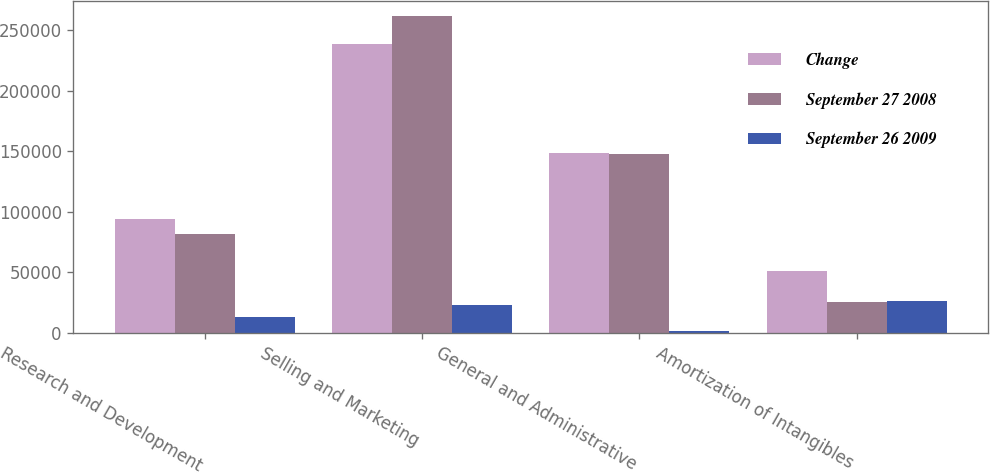<chart> <loc_0><loc_0><loc_500><loc_500><stacked_bar_chart><ecel><fcel>Research and Development<fcel>Selling and Marketing<fcel>General and Administrative<fcel>Amortization of Intangibles<nl><fcel>Change<fcel>94328<fcel>238977<fcel>148824<fcel>51210<nl><fcel>September 27 2008<fcel>81421<fcel>261524<fcel>147405<fcel>25227<nl><fcel>September 26 2009<fcel>12907<fcel>22547<fcel>1419<fcel>25983<nl></chart> 